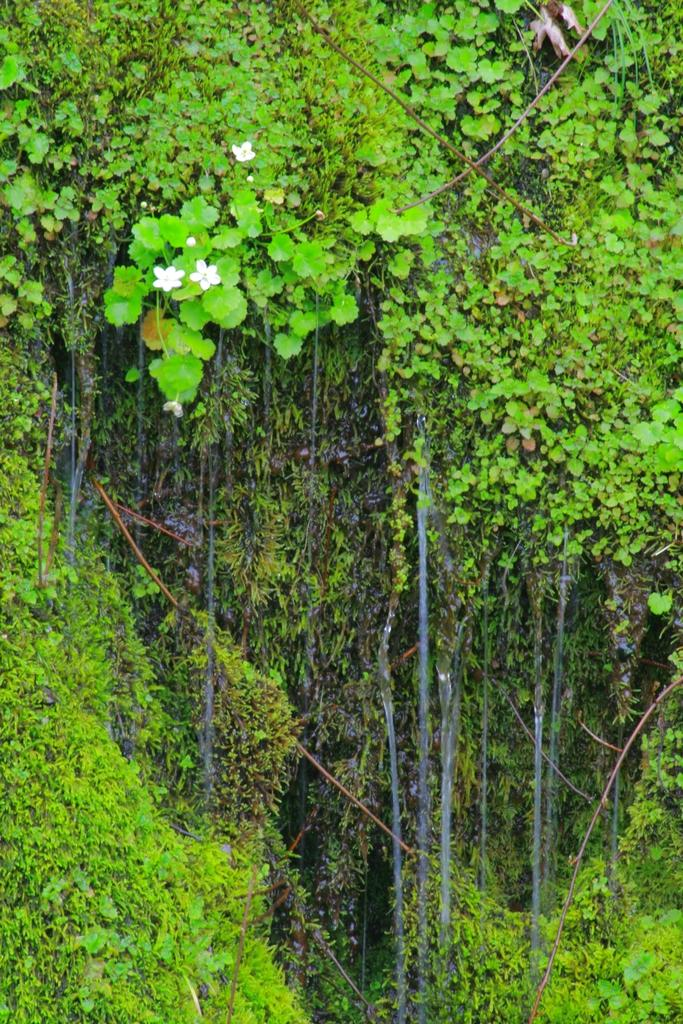What type of vegetation can be seen in the image? There are trees in the image. What color are the flowers in the image? The flowers in the image are white-colored. Is there a scarecrow in the image with a specific hair color? There is no scarecrow present in the image, and therefore no hair color can be determined. What type of insect can be seen interacting with the flowers in the image? There are no insects, such as beetles, visible in the image; only trees and white-colored flowers are present. 